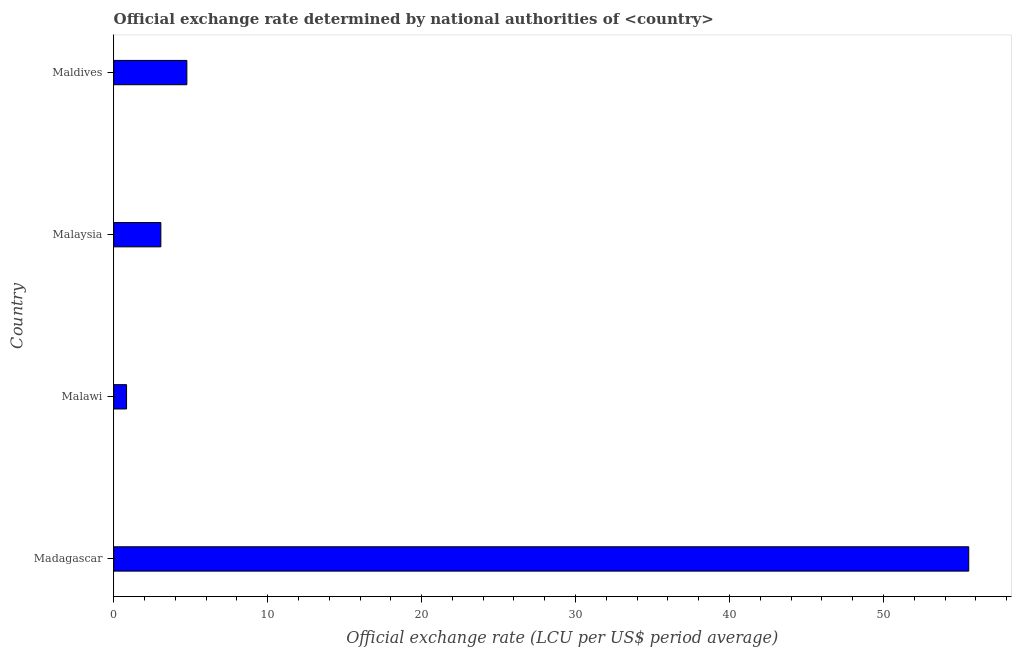What is the title of the graph?
Ensure brevity in your answer.  Official exchange rate determined by national authorities of <country>. What is the label or title of the X-axis?
Keep it short and to the point. Official exchange rate (LCU per US$ period average). What is the label or title of the Y-axis?
Your answer should be compact. Country. What is the official exchange rate in Maldives?
Provide a short and direct response. 4.75. Across all countries, what is the maximum official exchange rate?
Provide a succinct answer. 55.54. Across all countries, what is the minimum official exchange rate?
Provide a short and direct response. 0.83. In which country was the official exchange rate maximum?
Provide a succinct answer. Madagascar. In which country was the official exchange rate minimum?
Keep it short and to the point. Malawi. What is the sum of the official exchange rate?
Provide a succinct answer. 64.19. What is the difference between the official exchange rate in Malaysia and Maldives?
Ensure brevity in your answer.  -1.69. What is the average official exchange rate per country?
Your response must be concise. 16.05. What is the median official exchange rate?
Your response must be concise. 3.91. In how many countries, is the official exchange rate greater than 8 ?
Offer a very short reply. 1. What is the ratio of the official exchange rate in Malaysia to that in Maldives?
Keep it short and to the point. 0.64. Is the official exchange rate in Madagascar less than that in Malaysia?
Your answer should be very brief. No. Is the difference between the official exchange rate in Madagascar and Malawi greater than the difference between any two countries?
Your response must be concise. Yes. What is the difference between the highest and the second highest official exchange rate?
Provide a succinct answer. 50.79. Is the sum of the official exchange rate in Malawi and Malaysia greater than the maximum official exchange rate across all countries?
Offer a very short reply. No. What is the difference between the highest and the lowest official exchange rate?
Give a very brief answer. 54.71. In how many countries, is the official exchange rate greater than the average official exchange rate taken over all countries?
Offer a very short reply. 1. How many bars are there?
Provide a short and direct response. 4. How many countries are there in the graph?
Your response must be concise. 4. What is the difference between two consecutive major ticks on the X-axis?
Make the answer very short. 10. Are the values on the major ticks of X-axis written in scientific E-notation?
Your answer should be compact. No. What is the Official exchange rate (LCU per US$ period average) of Madagascar?
Offer a terse response. 55.54. What is the Official exchange rate (LCU per US$ period average) of Malawi?
Your answer should be very brief. 0.83. What is the Official exchange rate (LCU per US$ period average) in Malaysia?
Provide a short and direct response. 3.06. What is the Official exchange rate (LCU per US$ period average) of Maldives?
Provide a short and direct response. 4.75. What is the difference between the Official exchange rate (LCU per US$ period average) in Madagascar and Malawi?
Provide a short and direct response. 54.71. What is the difference between the Official exchange rate (LCU per US$ period average) in Madagascar and Malaysia?
Give a very brief answer. 52.48. What is the difference between the Official exchange rate (LCU per US$ period average) in Madagascar and Maldives?
Your response must be concise. 50.79. What is the difference between the Official exchange rate (LCU per US$ period average) in Malawi and Malaysia?
Ensure brevity in your answer.  -2.23. What is the difference between the Official exchange rate (LCU per US$ period average) in Malawi and Maldives?
Offer a terse response. -3.92. What is the difference between the Official exchange rate (LCU per US$ period average) in Malaysia and Maldives?
Make the answer very short. -1.69. What is the ratio of the Official exchange rate (LCU per US$ period average) in Madagascar to that in Malawi?
Offer a very short reply. 66.65. What is the ratio of the Official exchange rate (LCU per US$ period average) in Madagascar to that in Malaysia?
Your answer should be very brief. 18.14. What is the ratio of the Official exchange rate (LCU per US$ period average) in Madagascar to that in Maldives?
Offer a very short reply. 11.69. What is the ratio of the Official exchange rate (LCU per US$ period average) in Malawi to that in Malaysia?
Offer a terse response. 0.27. What is the ratio of the Official exchange rate (LCU per US$ period average) in Malawi to that in Maldives?
Offer a very short reply. 0.17. What is the ratio of the Official exchange rate (LCU per US$ period average) in Malaysia to that in Maldives?
Your response must be concise. 0.64. 